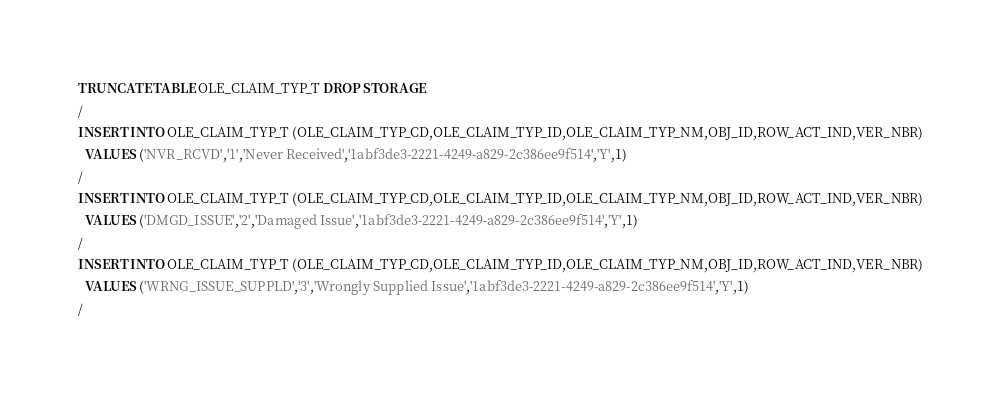Convert code to text. <code><loc_0><loc_0><loc_500><loc_500><_SQL_>TRUNCATE TABLE OLE_CLAIM_TYP_T DROP STORAGE
/
INSERT INTO OLE_CLAIM_TYP_T (OLE_CLAIM_TYP_CD,OLE_CLAIM_TYP_ID,OLE_CLAIM_TYP_NM,OBJ_ID,ROW_ACT_IND,VER_NBR)
  VALUES ('NVR_RCVD','1','Never Received','1abf3de3-2221-4249-a829-2c386ee9f514','Y',1)
/
INSERT INTO OLE_CLAIM_TYP_T (OLE_CLAIM_TYP_CD,OLE_CLAIM_TYP_ID,OLE_CLAIM_TYP_NM,OBJ_ID,ROW_ACT_IND,VER_NBR)
  VALUES ('DMGD_ISSUE','2','Damaged Issue','1abf3de3-2221-4249-a829-2c386ee9f514','Y',1)
/
INSERT INTO OLE_CLAIM_TYP_T (OLE_CLAIM_TYP_CD,OLE_CLAIM_TYP_ID,OLE_CLAIM_TYP_NM,OBJ_ID,ROW_ACT_IND,VER_NBR)
  VALUES ('WRNG_ISSUE_SUPPLD','3','Wrongly Supplied Issue','1abf3de3-2221-4249-a829-2c386ee9f514','Y',1)
/
</code> 